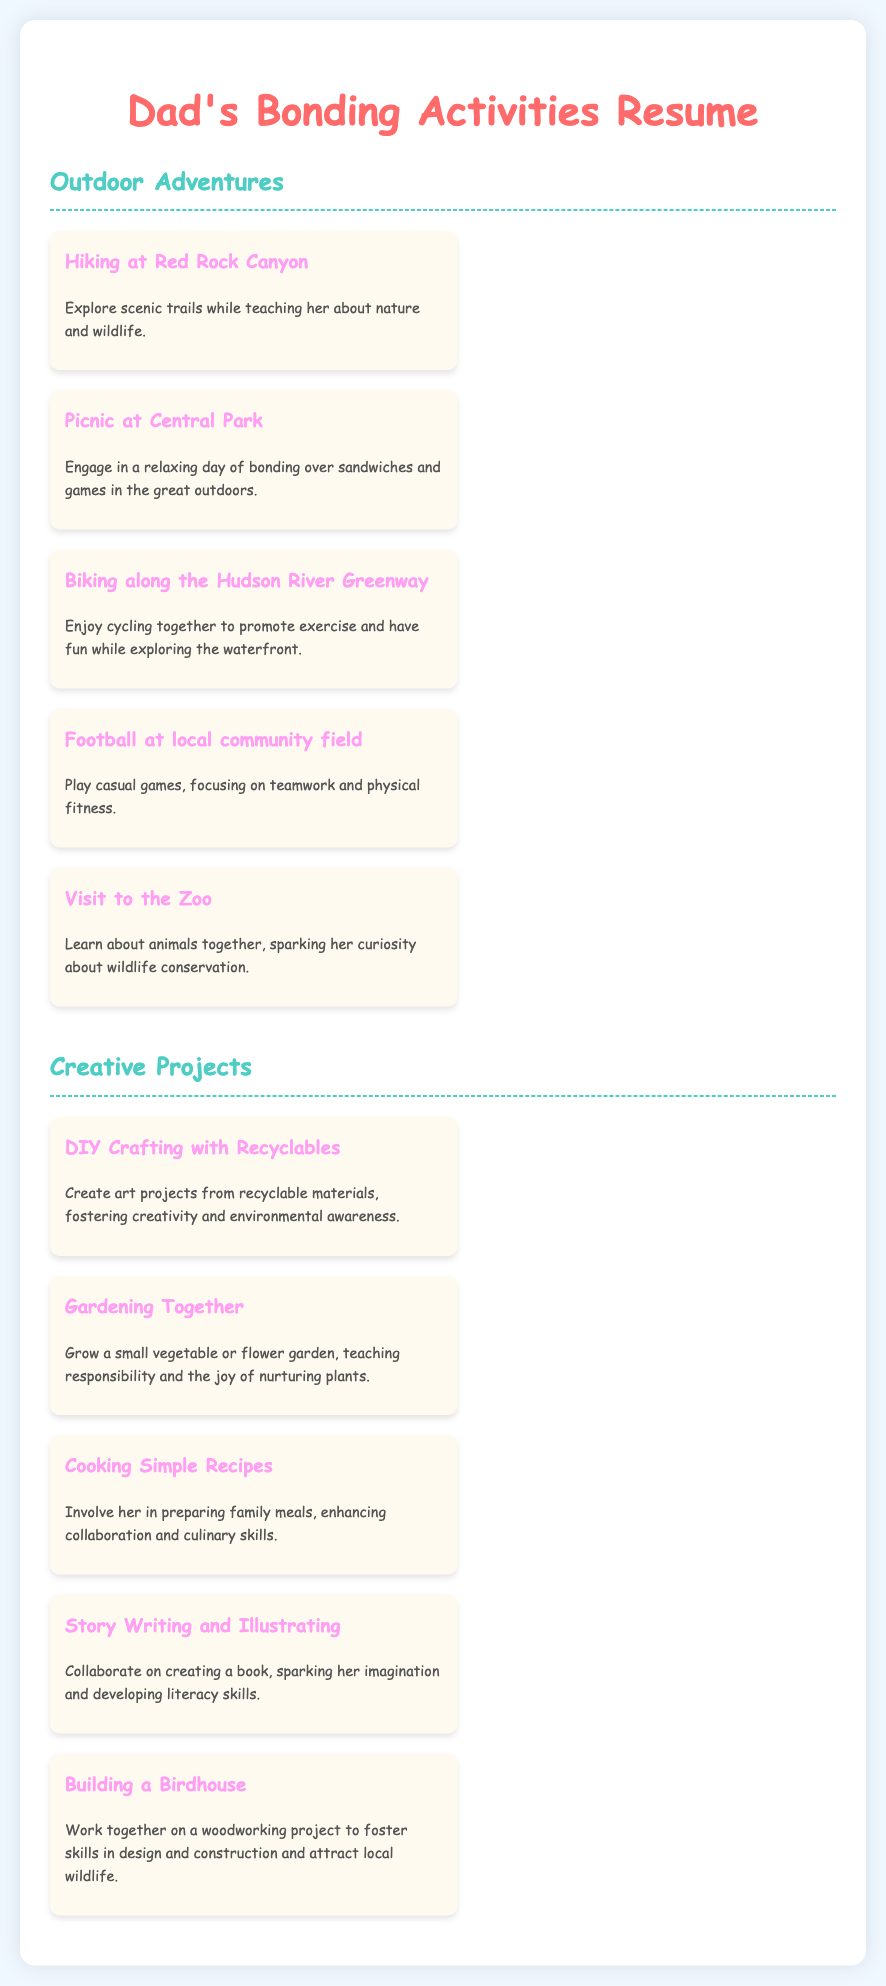What is the first outdoor adventure listed? The first outdoor adventure is the one mentioned at the top of the outdoor activities section in the document.
Answer: Hiking at Red Rock Canyon How many outdoor adventures are mentioned? The total number of outdoor adventures can be counted in the list provided under the Outdoor Adventures section.
Answer: 5 What type of project involves recyclables? This project is highlighted in the Creative Projects section as an activity using certain materials.
Answer: DIY Crafting with Recyclables Which activity teaches gardening skills? There is a specific creative project that focuses on growing plants and nurturing them.
Answer: Gardening Together What is the coloring theme for the document's title? The color used for the title is specified in the styling section of the HTML code.
Answer: #ff6b6b How many creative projects are listed? The total number of creative projects can be counted in the list provided under the Creative Projects section.
Answer: 5 What outdoor adventure encourages fitness? This outdoor activity promotes exercise and is aimed at physical activity with a group.
Answer: Football at local community field Which activity involves cooking? There is a specific project mentioned that includes preparing meals together.
Answer: Cooking Simple Recipes 